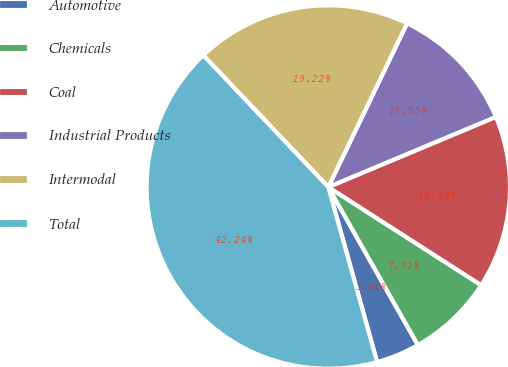Convert chart to OTSL. <chart><loc_0><loc_0><loc_500><loc_500><pie_chart><fcel>Automotive<fcel>Chemicals<fcel>Coal<fcel>Industrial Products<fcel>Intermodal<fcel>Total<nl><fcel>3.88%<fcel>7.71%<fcel>15.39%<fcel>11.55%<fcel>19.22%<fcel>42.24%<nl></chart> 